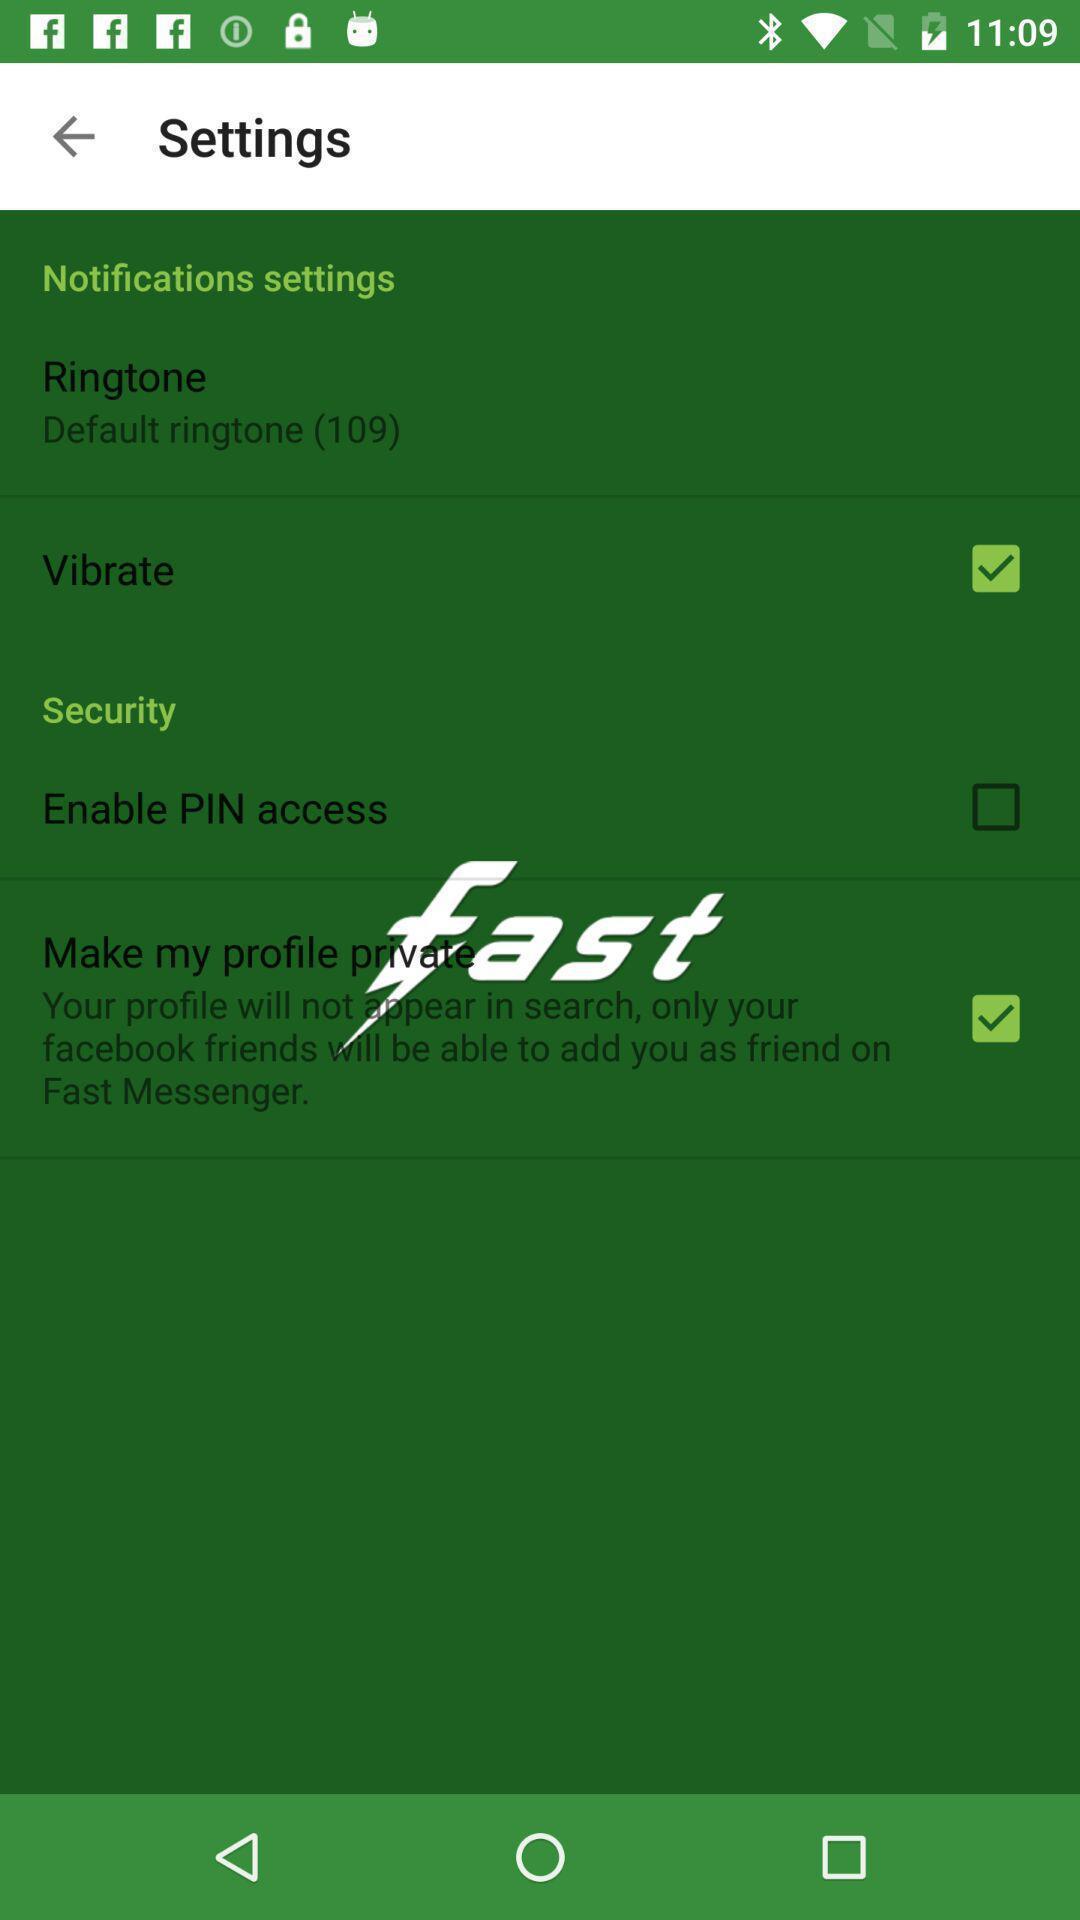Provide a detailed account of this screenshot. Screen showing settings page. 